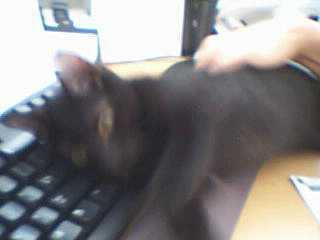Please narrate a possible scenario involving the main subject in the image. A person is gently petting a big black cat lying on a black keyboard on a wooden table; the cat seems to be enjoying the attention and appears to be in motion. Characterize the quality of the image and provide a reason. The image is of low quality, as it appears blurry due to the cat's motion. Describe the surface the cat is lying on and the material it is made of. The cat is lying on a wooden table or desk, which has a light brown color. State the approximate number of buttons on the keyboard. There are many buttons on the keyboard. Mention the background and the state of the image. The image has a white background and appears to be blurry due to the cat's motion. List three objects that are present and interacting in the image. A hand, a cat, and a keyboard are present and interacting in the image. Give a concise description of the entire scene in the image. A person is petting a large black cat that lies on a black keyboard on a wooden desk, while the cat's head and arms are stretched out, the scene is blurry with a white background. State the color of the keyboard and its keys. The keyboard is black, and its keys are also black. How many eyes are visible in the cat and what color are they? Two eyes are visible on the cat, and they appear to be yellow or green. What animal is featured in the image and what is the color of its fur? A cat with black fur is featured in the image. Does the cat have blue eyes? The captions mention that the cat has green or yellow eyes, so questioning if the cat has blue eyes is wrong. Is the table made of metal? The table is described as being wooden, so asking if it is made of metal is misleading and incorrect. Is the person wearing gloves while petting the cat? There is no mention of gloves in the captions. Asking this question adds extra information that is not present in the image and is misleading. Are the keyboard buttons blue? The captions mention that the buttons are black in color, so asking if they are blue is providing wrong information. Is the background green? The captions describe the background as being white, asking if the background is green is providing wrong attributes for the background. Is the cat white in color? The captions describe the cat as being black, so asking if the cat is white is misleading and incorrect. 